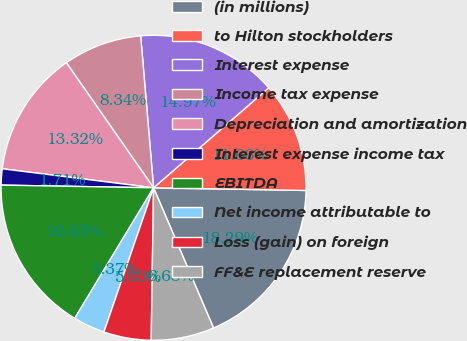Convert chart to OTSL. <chart><loc_0><loc_0><loc_500><loc_500><pie_chart><fcel>(in millions)<fcel>to Hilton stockholders<fcel>Interest expense<fcel>Income tax expense<fcel>Depreciation and amortization<fcel>Interest expense income tax<fcel>EBITDA<fcel>Net income attributable to<fcel>Loss (gain) on foreign<fcel>FF&E replacement reserve<nl><fcel>18.29%<fcel>11.66%<fcel>14.97%<fcel>8.34%<fcel>13.32%<fcel>1.71%<fcel>16.63%<fcel>3.37%<fcel>5.03%<fcel>6.68%<nl></chart> 